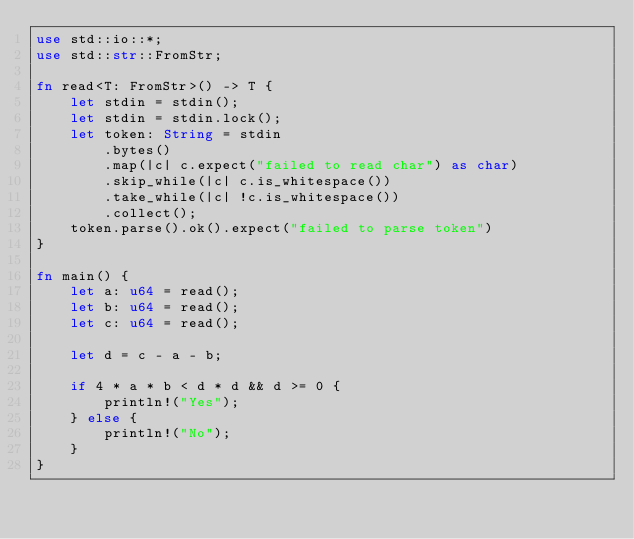Convert code to text. <code><loc_0><loc_0><loc_500><loc_500><_Rust_>use std::io::*;
use std::str::FromStr;

fn read<T: FromStr>() -> T {
    let stdin = stdin();
    let stdin = stdin.lock();
    let token: String = stdin
        .bytes()
        .map(|c| c.expect("failed to read char") as char) 
        .skip_while(|c| c.is_whitespace())
        .take_while(|c| !c.is_whitespace())
        .collect();
    token.parse().ok().expect("failed to parse token")
}
    
fn main() {
    let a: u64 = read();
    let b: u64 = read();
    let c: u64 = read();

    let d = c - a - b;
    
    if 4 * a * b < d * d && d >= 0 {
        println!("Yes");
    } else {
        println!("No");
    }
}
</code> 